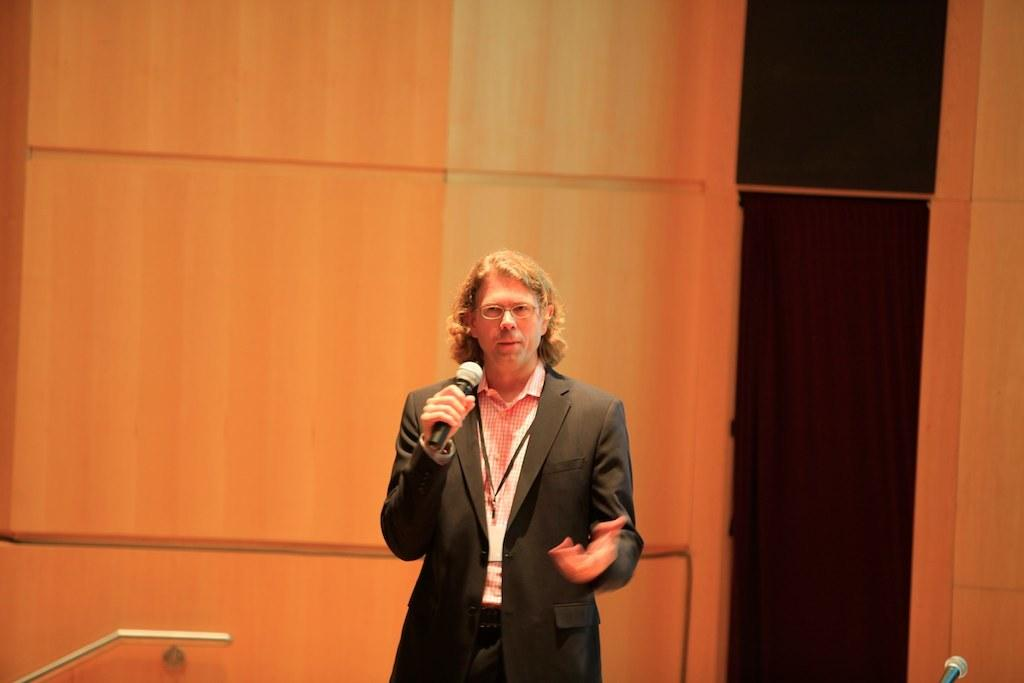What is the main subject of the image? There is a person in the image. What is the person wearing? The person is wearing a black suit. What is the person doing in the image? The person is standing and speaking. What object is in front of the person? There is a microphone in front of the person. Are there any other microphones visible in the image? Yes, there is another microphone in the right corner of the image. What type of train can be seen in the image? There is no train present in the image. How many ducks are visible in the image? There are no ducks present in the image. 